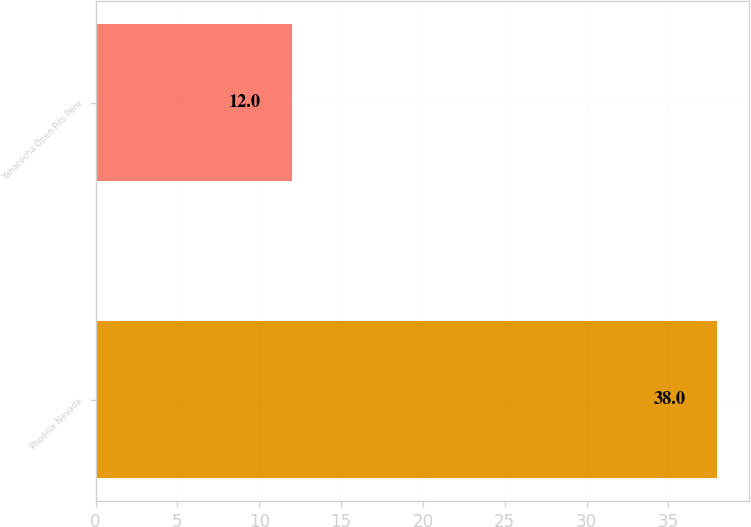Convert chart. <chart><loc_0><loc_0><loc_500><loc_500><bar_chart><fcel>Phoenix Nevada<fcel>Yanacocha Open Pits Peru<nl><fcel>38<fcel>12<nl></chart> 